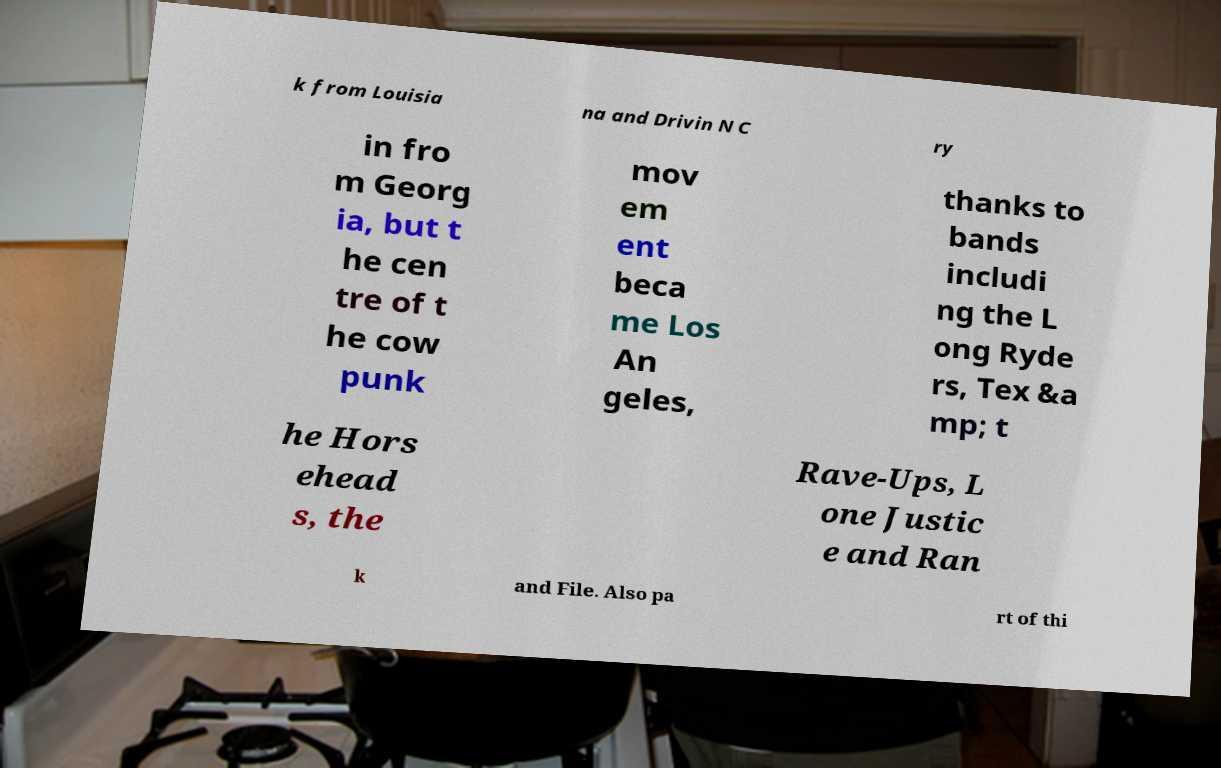Please read and relay the text visible in this image. What does it say? k from Louisia na and Drivin N C ry in fro m Georg ia, but t he cen tre of t he cow punk mov em ent beca me Los An geles, thanks to bands includi ng the L ong Ryde rs, Tex &a mp; t he Hors ehead s, the Rave-Ups, L one Justic e and Ran k and File. Also pa rt of thi 